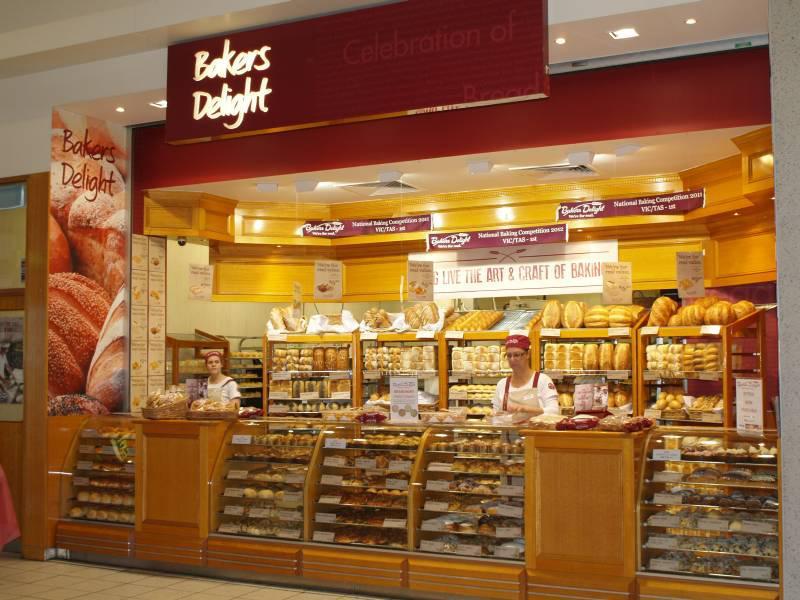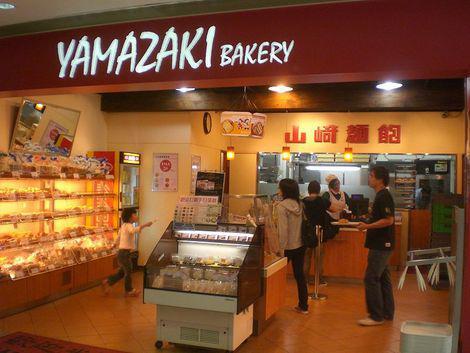The first image is the image on the left, the second image is the image on the right. Examine the images to the left and right. Is the description "An image includes a person behind a bakery counter and at least one back-turned person standing in front of the counter." accurate? Answer yes or no. Yes. 